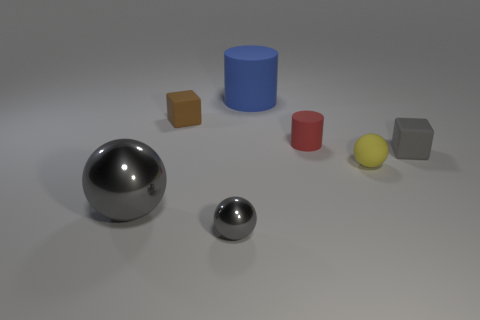What shape is the small gray thing that is to the right of the metallic thing that is in front of the large gray metal thing?
Offer a terse response. Cube. There is a rubber cube right of the cylinder behind the red rubber object; what number of yellow rubber balls are behind it?
Ensure brevity in your answer.  0. Are there fewer large blue things that are right of the large gray metal thing than large gray rubber cylinders?
Ensure brevity in your answer.  No. Is there anything else that has the same shape as the big matte object?
Provide a short and direct response. Yes. What shape is the small thing that is in front of the yellow ball?
Your answer should be very brief. Sphere. There is a tiny gray thing right of the blue thing behind the small rubber cube on the right side of the blue matte cylinder; what shape is it?
Provide a succinct answer. Cube. What number of things are small brown matte blocks or spheres?
Offer a terse response. 4. Is the shape of the big object right of the tiny gray metallic object the same as the yellow matte thing that is right of the large sphere?
Give a very brief answer. No. How many things are in front of the brown block and left of the small gray metal sphere?
Make the answer very short. 1. What number of other objects are the same size as the blue cylinder?
Your answer should be compact. 1. 